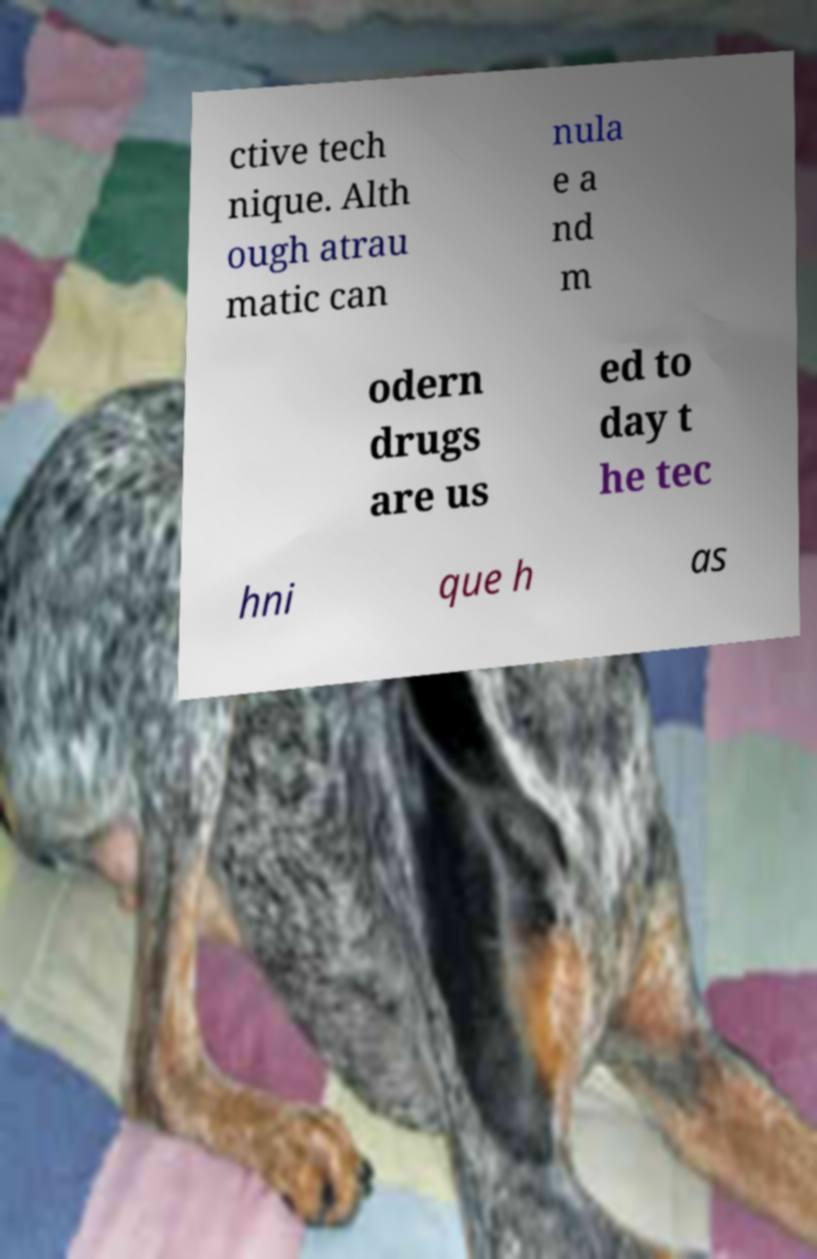What messages or text are displayed in this image? I need them in a readable, typed format. ctive tech nique. Alth ough atrau matic can nula e a nd m odern drugs are us ed to day t he tec hni que h as 